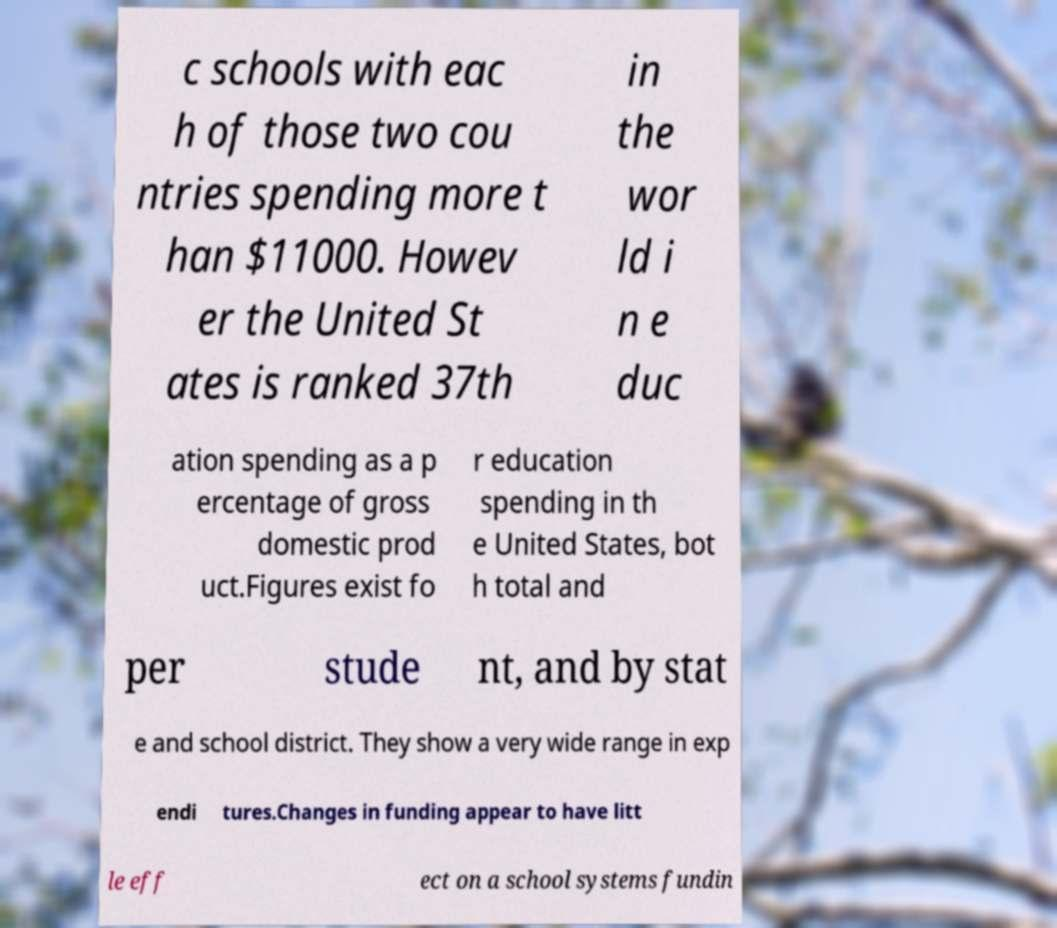There's text embedded in this image that I need extracted. Can you transcribe it verbatim? c schools with eac h of those two cou ntries spending more t han $11000. Howev er the United St ates is ranked 37th in the wor ld i n e duc ation spending as a p ercentage of gross domestic prod uct.Figures exist fo r education spending in th e United States, bot h total and per stude nt, and by stat e and school district. They show a very wide range in exp endi tures.Changes in funding appear to have litt le eff ect on a school systems fundin 